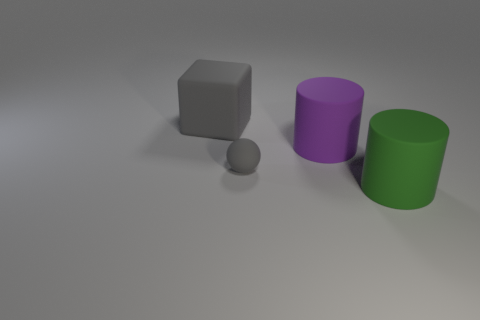Is there any other thing that has the same size as the gray sphere?
Ensure brevity in your answer.  No. There is a large thing that is the same color as the ball; what is it made of?
Make the answer very short. Rubber. What is the shape of the big object on the right side of the big purple matte thing?
Your response must be concise. Cylinder. How many blocks are on the right side of the object that is behind the big rubber cylinder left of the green cylinder?
Provide a short and direct response. 0. There is a green rubber cylinder; does it have the same size as the gray thing behind the tiny gray rubber thing?
Provide a succinct answer. Yes. There is a cylinder to the right of the matte cylinder that is behind the large green rubber object; what is its size?
Give a very brief answer. Large. What number of blue spheres have the same material as the large gray object?
Give a very brief answer. 0. Are any matte spheres visible?
Make the answer very short. Yes. What size is the matte cylinder that is to the right of the big purple object?
Keep it short and to the point. Large. How many other blocks are the same color as the large rubber cube?
Provide a short and direct response. 0. 